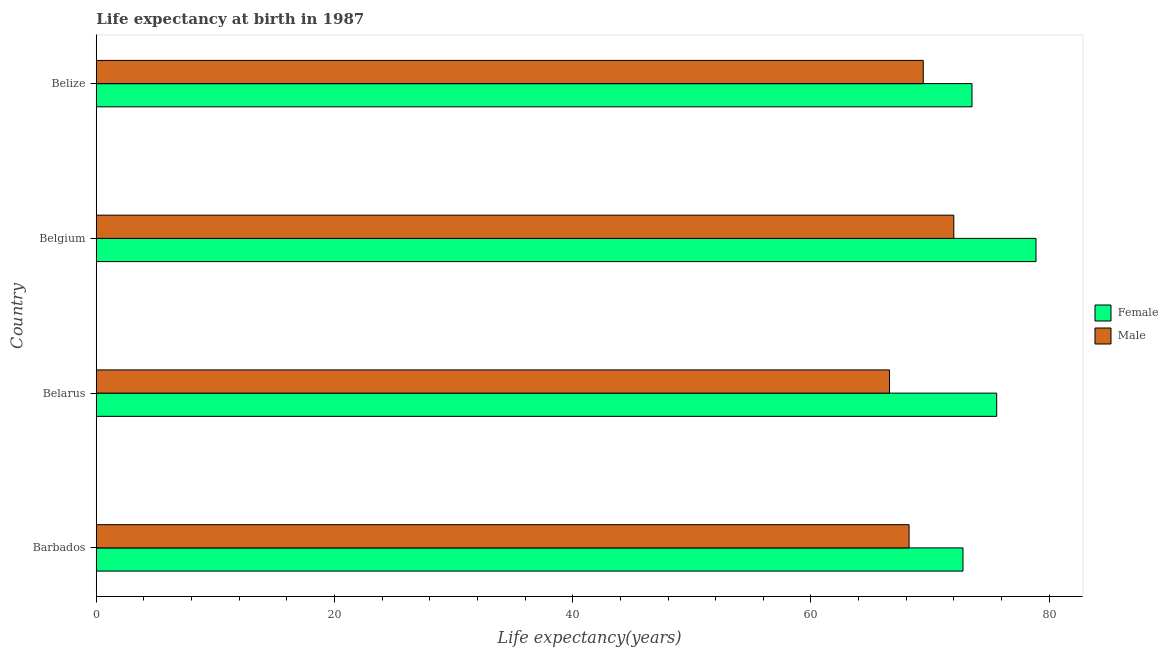How many different coloured bars are there?
Your answer should be compact. 2. How many groups of bars are there?
Offer a terse response. 4. Are the number of bars per tick equal to the number of legend labels?
Your answer should be very brief. Yes. What is the life expectancy(female) in Belarus?
Provide a short and direct response. 75.6. Across all countries, what is the minimum life expectancy(male)?
Offer a very short reply. 66.6. In which country was the life expectancy(female) maximum?
Offer a very short reply. Belgium. In which country was the life expectancy(male) minimum?
Offer a terse response. Belarus. What is the total life expectancy(male) in the graph?
Make the answer very short. 276.28. What is the difference between the life expectancy(female) in Belarus and that in Belgium?
Make the answer very short. -3.3. What is the difference between the life expectancy(male) in Belgium and the life expectancy(female) in Belarus?
Provide a succinct answer. -3.6. What is the average life expectancy(male) per country?
Give a very brief answer. 69.07. What is the difference between the life expectancy(female) and life expectancy(male) in Barbados?
Ensure brevity in your answer.  4.53. What is the ratio of the life expectancy(female) in Barbados to that in Belarus?
Give a very brief answer. 0.96. Is the life expectancy(male) in Barbados less than that in Belgium?
Your response must be concise. Yes. What is the difference between the highest and the second highest life expectancy(male)?
Your answer should be very brief. 2.57. What is the difference between the highest and the lowest life expectancy(female)?
Your answer should be compact. 6.13. Is the sum of the life expectancy(female) in Belarus and Belgium greater than the maximum life expectancy(male) across all countries?
Give a very brief answer. Yes. What is the title of the graph?
Your answer should be compact. Life expectancy at birth in 1987. Does "Grants" appear as one of the legend labels in the graph?
Your answer should be very brief. No. What is the label or title of the X-axis?
Provide a succinct answer. Life expectancy(years). What is the label or title of the Y-axis?
Ensure brevity in your answer.  Country. What is the Life expectancy(years) in Female in Barbados?
Make the answer very short. 72.77. What is the Life expectancy(years) in Male in Barbados?
Give a very brief answer. 68.24. What is the Life expectancy(years) of Female in Belarus?
Your answer should be very brief. 75.6. What is the Life expectancy(years) in Male in Belarus?
Provide a short and direct response. 66.6. What is the Life expectancy(years) in Female in Belgium?
Keep it short and to the point. 78.9. What is the Life expectancy(years) in Female in Belize?
Your response must be concise. 73.53. What is the Life expectancy(years) of Male in Belize?
Give a very brief answer. 69.43. Across all countries, what is the maximum Life expectancy(years) of Female?
Ensure brevity in your answer.  78.9. Across all countries, what is the minimum Life expectancy(years) of Female?
Provide a succinct answer. 72.77. Across all countries, what is the minimum Life expectancy(years) of Male?
Provide a succinct answer. 66.6. What is the total Life expectancy(years) of Female in the graph?
Your response must be concise. 300.8. What is the total Life expectancy(years) of Male in the graph?
Provide a succinct answer. 276.28. What is the difference between the Life expectancy(years) of Female in Barbados and that in Belarus?
Keep it short and to the point. -2.83. What is the difference between the Life expectancy(years) in Male in Barbados and that in Belarus?
Provide a succinct answer. 1.64. What is the difference between the Life expectancy(years) of Female in Barbados and that in Belgium?
Keep it short and to the point. -6.13. What is the difference between the Life expectancy(years) of Male in Barbados and that in Belgium?
Your response must be concise. -3.76. What is the difference between the Life expectancy(years) in Female in Barbados and that in Belize?
Offer a very short reply. -0.76. What is the difference between the Life expectancy(years) in Male in Barbados and that in Belize?
Your answer should be compact. -1.19. What is the difference between the Life expectancy(years) in Male in Belarus and that in Belgium?
Ensure brevity in your answer.  -5.4. What is the difference between the Life expectancy(years) of Female in Belarus and that in Belize?
Your answer should be very brief. 2.07. What is the difference between the Life expectancy(years) in Male in Belarus and that in Belize?
Your answer should be compact. -2.83. What is the difference between the Life expectancy(years) of Female in Belgium and that in Belize?
Offer a terse response. 5.37. What is the difference between the Life expectancy(years) in Male in Belgium and that in Belize?
Offer a very short reply. 2.57. What is the difference between the Life expectancy(years) in Female in Barbados and the Life expectancy(years) in Male in Belarus?
Provide a succinct answer. 6.17. What is the difference between the Life expectancy(years) of Female in Barbados and the Life expectancy(years) of Male in Belgium?
Provide a succinct answer. 0.77. What is the difference between the Life expectancy(years) of Female in Barbados and the Life expectancy(years) of Male in Belize?
Offer a terse response. 3.34. What is the difference between the Life expectancy(years) of Female in Belarus and the Life expectancy(years) of Male in Belize?
Provide a succinct answer. 6.17. What is the difference between the Life expectancy(years) of Female in Belgium and the Life expectancy(years) of Male in Belize?
Offer a very short reply. 9.47. What is the average Life expectancy(years) in Female per country?
Provide a succinct answer. 75.2. What is the average Life expectancy(years) in Male per country?
Offer a terse response. 69.07. What is the difference between the Life expectancy(years) in Female and Life expectancy(years) in Male in Barbados?
Offer a very short reply. 4.53. What is the difference between the Life expectancy(years) in Female and Life expectancy(years) in Male in Belize?
Your answer should be very brief. 4.09. What is the ratio of the Life expectancy(years) in Female in Barbados to that in Belarus?
Ensure brevity in your answer.  0.96. What is the ratio of the Life expectancy(years) of Male in Barbados to that in Belarus?
Give a very brief answer. 1.02. What is the ratio of the Life expectancy(years) of Female in Barbados to that in Belgium?
Your response must be concise. 0.92. What is the ratio of the Life expectancy(years) in Male in Barbados to that in Belgium?
Your answer should be compact. 0.95. What is the ratio of the Life expectancy(years) in Female in Barbados to that in Belize?
Give a very brief answer. 0.99. What is the ratio of the Life expectancy(years) in Male in Barbados to that in Belize?
Provide a short and direct response. 0.98. What is the ratio of the Life expectancy(years) of Female in Belarus to that in Belgium?
Make the answer very short. 0.96. What is the ratio of the Life expectancy(years) of Male in Belarus to that in Belgium?
Make the answer very short. 0.93. What is the ratio of the Life expectancy(years) of Female in Belarus to that in Belize?
Keep it short and to the point. 1.03. What is the ratio of the Life expectancy(years) of Male in Belarus to that in Belize?
Your response must be concise. 0.96. What is the ratio of the Life expectancy(years) in Female in Belgium to that in Belize?
Provide a succinct answer. 1.07. What is the ratio of the Life expectancy(years) in Male in Belgium to that in Belize?
Provide a short and direct response. 1.04. What is the difference between the highest and the second highest Life expectancy(years) in Female?
Provide a succinct answer. 3.3. What is the difference between the highest and the second highest Life expectancy(years) in Male?
Give a very brief answer. 2.57. What is the difference between the highest and the lowest Life expectancy(years) in Female?
Give a very brief answer. 6.13. What is the difference between the highest and the lowest Life expectancy(years) of Male?
Provide a succinct answer. 5.4. 